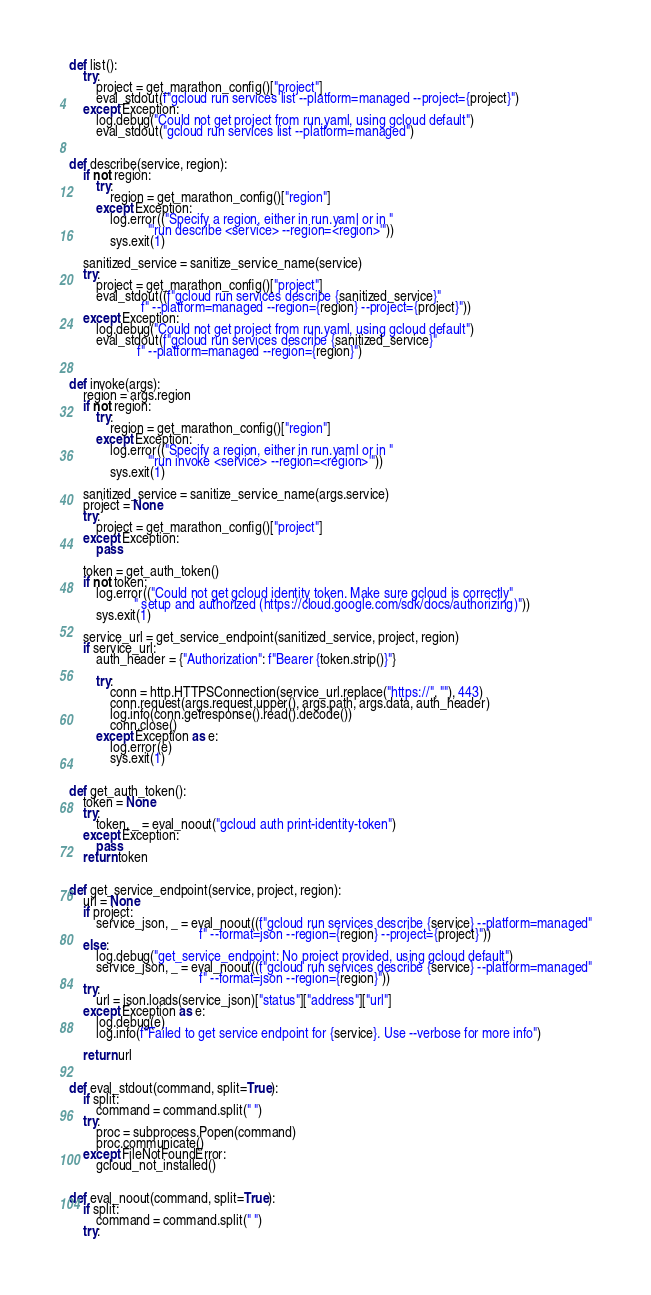<code> <loc_0><loc_0><loc_500><loc_500><_Python_>
def list():
    try:
        project = get_marathon_config()["project"]
        eval_stdout(f"gcloud run services list --platform=managed --project={project}")
    except Exception:
        log.debug("Could not get project from run.yaml, using gcloud default")
        eval_stdout("gcloud run services list --platform=managed")


def describe(service, region):
    if not region:
        try:
            region = get_marathon_config()["region"]
        except Exception:
            log.error(("Specify a region, either in run.yaml or in "
                       "'run describe <service> --region=<region>'"))
            sys.exit(1)

    sanitized_service = sanitize_service_name(service)
    try:
        project = get_marathon_config()["project"]
        eval_stdout((f"gcloud run services describe {sanitized_service}"
                     f" --platform=managed --region={region} --project={project}"))
    except Exception:
        log.debug("Could not get project from run.yaml, using gcloud default")
        eval_stdout(f"gcloud run services describe {sanitized_service}"
                    f" --platform=managed --region={region}")


def invoke(args):
    region = args.region
    if not region:
        try:
            region = get_marathon_config()["region"]
        except Exception:
            log.error(("Specify a region, either in run.yaml or in "
                       "'run invoke <service> --region=<region>'"))
            sys.exit(1)

    sanitized_service = sanitize_service_name(args.service)
    project = None
    try:
        project = get_marathon_config()["project"]
    except Exception:
        pass

    token = get_auth_token()
    if not token:
        log.error(("Could not get gcloud identity token. Make sure gcloud is correctly"
                   " setup and authorized (https://cloud.google.com/sdk/docs/authorizing)"))
        sys.exit(1)

    service_url = get_service_endpoint(sanitized_service, project, region)
    if service_url:
        auth_header = {"Authorization": f"Bearer {token.strip()}"}

        try:
            conn = http.HTTPSConnection(service_url.replace("https://", ""), 443)
            conn.request(args.request.upper(), args.path, args.data, auth_header)
            log.info(conn.getresponse().read().decode())
            conn.close()
        except Exception as e:
            log.error(e)
            sys.exit(1)


def get_auth_token():
    token = None
    try:
        token, _ = eval_noout("gcloud auth print-identity-token")
    except Exception:
        pass
    return token


def get_service_endpoint(service, project, region):
    url = None
    if project:
        service_json, _ = eval_noout((f"gcloud run services describe {service} --platform=managed"
                                      f" --format=json --region={region} --project={project}"))
    else:
        log.debug("get_service_endpoint: No project provided, using gcloud default")
        service_json, _ = eval_noout((f"gcloud run services describe {service} --platform=managed"
                                      f" --format=json --region={region}"))
    try:
        url = json.loads(service_json)["status"]["address"]["url"]
    except Exception as e:
        log.debug(e)
        log.info(f"Failed to get service endpoint for {service}. Use --verbose for more info")

    return url


def eval_stdout(command, split=True):
    if split:
        command = command.split(" ")
    try:
        proc = subprocess.Popen(command)
        proc.communicate()
    except FileNotFoundError:
        gcloud_not_installed()


def eval_noout(command, split=True):
    if split:
        command = command.split(" ")
    try:</code> 